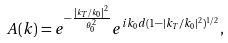Convert formula to latex. <formula><loc_0><loc_0><loc_500><loc_500>A ( k ) = e ^ { - \frac { \left | k _ { T } / k _ { 0 } \right | ^ { 2 } } { \theta _ { 0 } ^ { 2 } } } e ^ { i k _ { 0 } d ( 1 - \left | k _ { T } \right / k _ { 0 } | ^ { 2 } ) ^ { 1 / 2 } } ,</formula> 